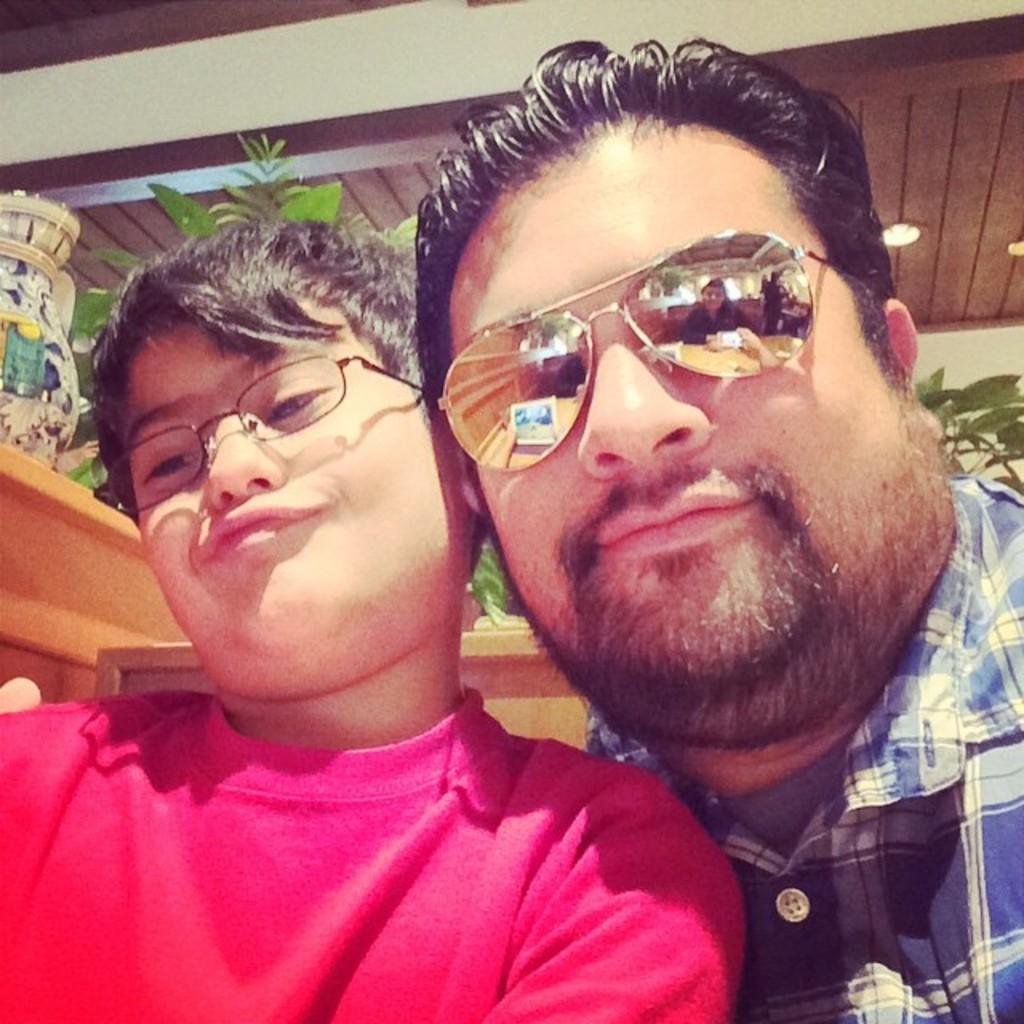Please provide a concise description of this image. In front of the image there are two people. Behind them there are plants and a pot on the platform. On top of the image there is a light. 